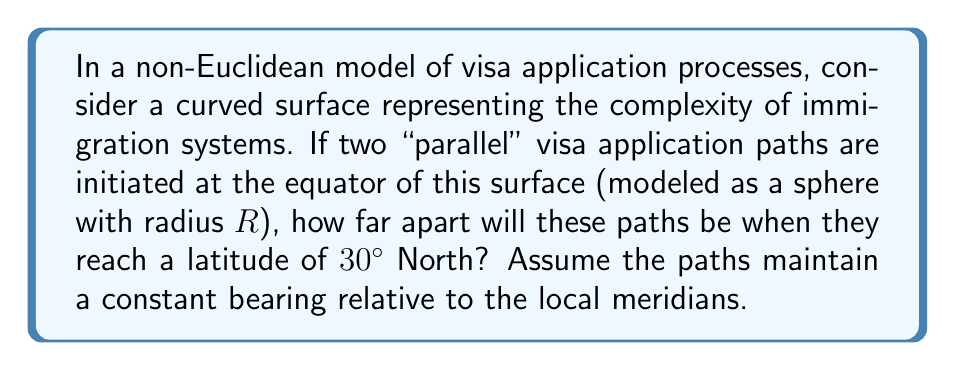Can you answer this question? Let's approach this step-by-step:

1) In spherical geometry, "parallel" lines (geodesics) that start at the equator and maintain a constant bearing relative to meridians are great circles.

2) These great circles will intersect at the poles, unlike parallel lines in Euclidean geometry.

3) The distance between these paths at any latitude is an arc of a small circle parallel to the equator.

4) The radius of this small circle at latitude $\phi$ is $R \cos\phi$, where $R$ is the radius of the sphere.

5) The arc length $s$ between the two paths at latitude $\phi$ is given by:

   $$s = R \cos\phi \cdot \theta$$

   where $\theta$ is the angle between the two paths in radians.

6) To find $\theta$, we can use the formula for the angle between two great circles at the equator:

   $$\cos\theta = \sin^2\phi$$

   where $\phi$ is the latitude where the paths intersect (in this case, at the poles, so $\phi = 90°$).

7) Solving for $\theta$:

   $$\theta = \arccos(\sin^2 90°) = \arccos(1) = 0$$

8) Now, we can calculate the distance at $30°$ North:

   $$s = R \cos(30°) \cdot 0 = 0$$

This result shows that in this non-Euclidean model, visa application processes that start "parallel" at the equator will converge as they progress, symbolizing how seemingly separate immigration paths may lead to similar outcomes in a complex system.
Answer: $0$ 